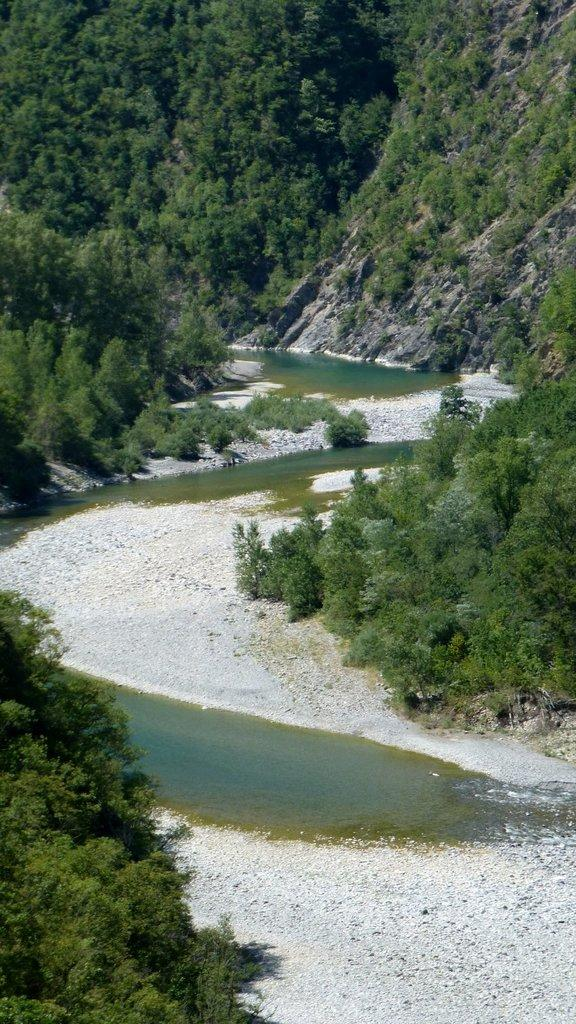What type of body of water is in the image? There is a small water lake in the image. What natural features can be seen in the background? Mountains are visible in the image. What type of vegetation is present in the image? Trees are present in the image. What type of development can be seen near the water lake in the image? There is no development or buildings visible in the image; it primarily features natural elements such as the water lake, mountains, and trees. 